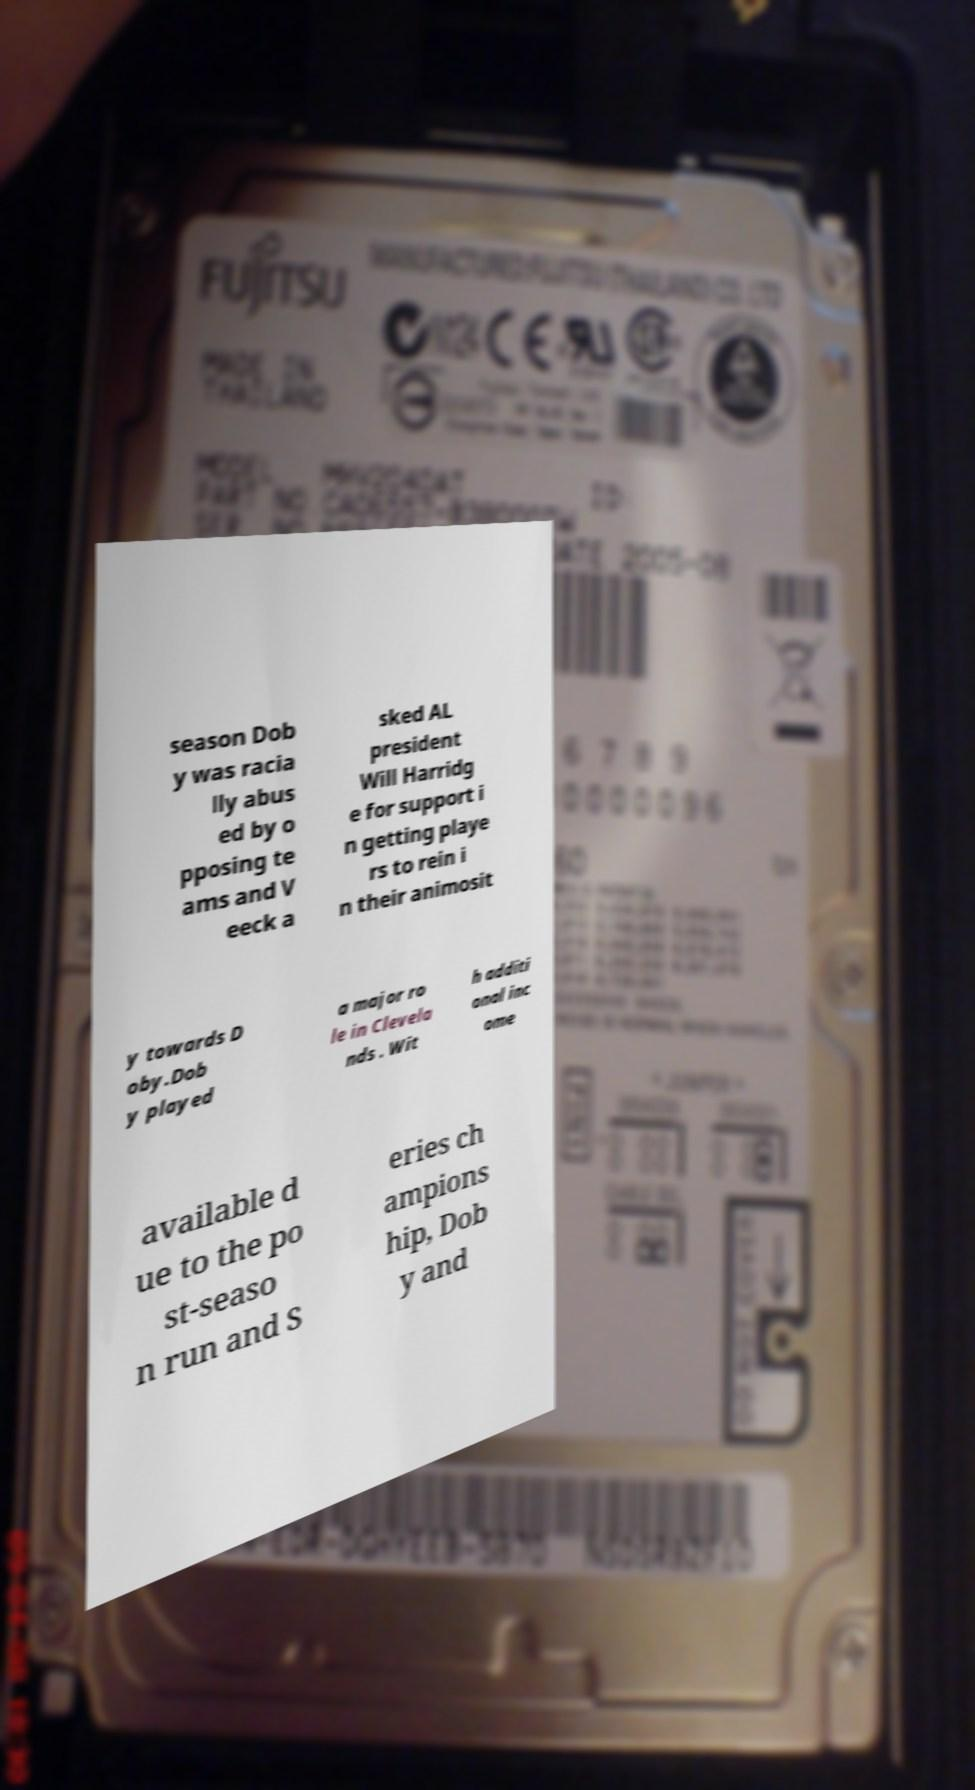Could you assist in decoding the text presented in this image and type it out clearly? season Dob y was racia lly abus ed by o pposing te ams and V eeck a sked AL president Will Harridg e for support i n getting playe rs to rein i n their animosit y towards D oby.Dob y played a major ro le in Clevela nds . Wit h additi onal inc ome available d ue to the po st-seaso n run and S eries ch ampions hip, Dob y and 